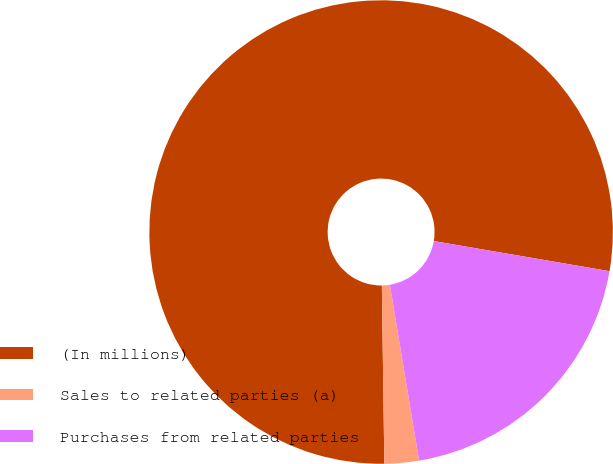<chart> <loc_0><loc_0><loc_500><loc_500><pie_chart><fcel>(In millions)<fcel>Sales to related parties (a)<fcel>Purchases from related parties<nl><fcel>77.93%<fcel>2.4%<fcel>19.68%<nl></chart> 